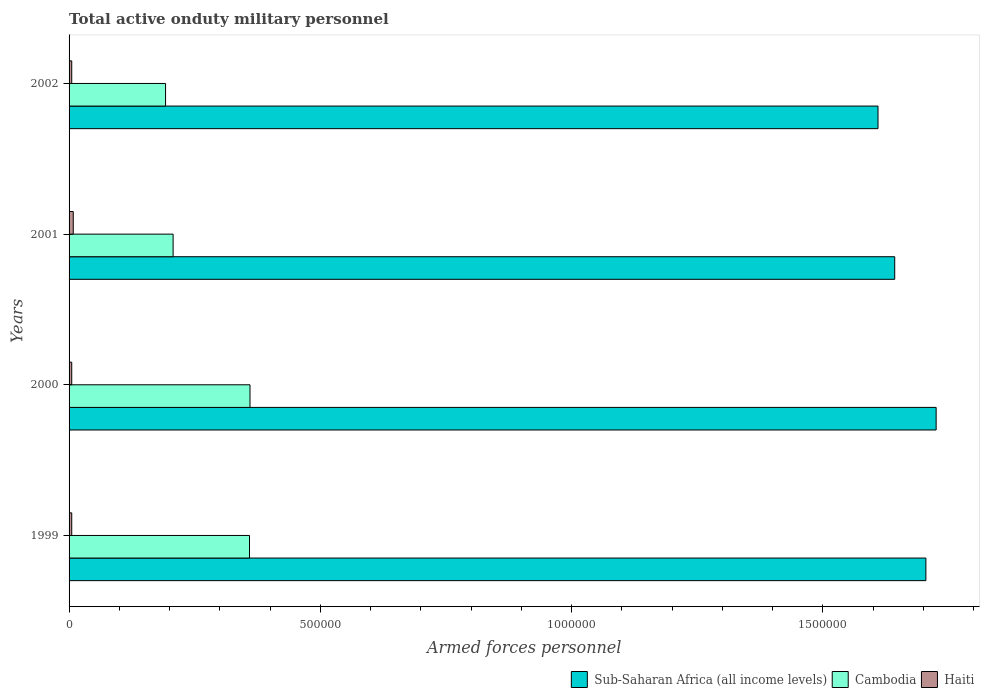How many different coloured bars are there?
Your answer should be compact. 3. How many groups of bars are there?
Your response must be concise. 4. Are the number of bars on each tick of the Y-axis equal?
Give a very brief answer. Yes. How many bars are there on the 3rd tick from the bottom?
Offer a very short reply. 3. What is the number of armed forces personnel in Sub-Saharan Africa (all income levels) in 2002?
Your answer should be compact. 1.61e+06. Across all years, what is the maximum number of armed forces personnel in Cambodia?
Provide a short and direct response. 3.60e+05. Across all years, what is the minimum number of armed forces personnel in Sub-Saharan Africa (all income levels)?
Your answer should be compact. 1.61e+06. In which year was the number of armed forces personnel in Haiti maximum?
Provide a short and direct response. 2001. In which year was the number of armed forces personnel in Sub-Saharan Africa (all income levels) minimum?
Give a very brief answer. 2002. What is the total number of armed forces personnel in Cambodia in the graph?
Ensure brevity in your answer.  1.12e+06. What is the difference between the number of armed forces personnel in Haiti in 1999 and that in 2000?
Offer a terse response. 0. What is the difference between the number of armed forces personnel in Sub-Saharan Africa (all income levels) in 2001 and the number of armed forces personnel in Cambodia in 2002?
Your response must be concise. 1.45e+06. What is the average number of armed forces personnel in Cambodia per year?
Offer a very short reply. 2.80e+05. In the year 2000, what is the difference between the number of armed forces personnel in Sub-Saharan Africa (all income levels) and number of armed forces personnel in Haiti?
Your answer should be compact. 1.72e+06. What is the ratio of the number of armed forces personnel in Cambodia in 2000 to that in 2002?
Ensure brevity in your answer.  1.88. Is the difference between the number of armed forces personnel in Sub-Saharan Africa (all income levels) in 1999 and 2002 greater than the difference between the number of armed forces personnel in Haiti in 1999 and 2002?
Your answer should be compact. Yes. What is the difference between the highest and the second highest number of armed forces personnel in Haiti?
Provide a succinct answer. 3000. What is the difference between the highest and the lowest number of armed forces personnel in Haiti?
Make the answer very short. 3000. In how many years, is the number of armed forces personnel in Cambodia greater than the average number of armed forces personnel in Cambodia taken over all years?
Provide a succinct answer. 2. Is the sum of the number of armed forces personnel in Sub-Saharan Africa (all income levels) in 2001 and 2002 greater than the maximum number of armed forces personnel in Cambodia across all years?
Offer a terse response. Yes. What does the 2nd bar from the top in 2000 represents?
Provide a succinct answer. Cambodia. What does the 2nd bar from the bottom in 1999 represents?
Keep it short and to the point. Cambodia. Is it the case that in every year, the sum of the number of armed forces personnel in Cambodia and number of armed forces personnel in Haiti is greater than the number of armed forces personnel in Sub-Saharan Africa (all income levels)?
Your response must be concise. No. Are all the bars in the graph horizontal?
Your answer should be very brief. Yes. How many years are there in the graph?
Ensure brevity in your answer.  4. Does the graph contain grids?
Make the answer very short. No. How many legend labels are there?
Provide a short and direct response. 3. What is the title of the graph?
Provide a succinct answer. Total active onduty military personnel. What is the label or title of the X-axis?
Offer a very short reply. Armed forces personnel. What is the label or title of the Y-axis?
Give a very brief answer. Years. What is the Armed forces personnel of Sub-Saharan Africa (all income levels) in 1999?
Offer a terse response. 1.70e+06. What is the Armed forces personnel in Cambodia in 1999?
Your answer should be compact. 3.59e+05. What is the Armed forces personnel in Haiti in 1999?
Offer a very short reply. 5300. What is the Armed forces personnel in Sub-Saharan Africa (all income levels) in 2000?
Your response must be concise. 1.73e+06. What is the Armed forces personnel of Cambodia in 2000?
Provide a short and direct response. 3.60e+05. What is the Armed forces personnel in Haiti in 2000?
Offer a terse response. 5300. What is the Armed forces personnel in Sub-Saharan Africa (all income levels) in 2001?
Keep it short and to the point. 1.64e+06. What is the Armed forces personnel of Cambodia in 2001?
Provide a succinct answer. 2.07e+05. What is the Armed forces personnel of Haiti in 2001?
Provide a succinct answer. 8300. What is the Armed forces personnel in Sub-Saharan Africa (all income levels) in 2002?
Provide a short and direct response. 1.61e+06. What is the Armed forces personnel in Cambodia in 2002?
Provide a succinct answer. 1.92e+05. What is the Armed forces personnel in Haiti in 2002?
Make the answer very short. 5300. Across all years, what is the maximum Armed forces personnel in Sub-Saharan Africa (all income levels)?
Your answer should be very brief. 1.73e+06. Across all years, what is the maximum Armed forces personnel in Cambodia?
Offer a terse response. 3.60e+05. Across all years, what is the maximum Armed forces personnel of Haiti?
Keep it short and to the point. 8300. Across all years, what is the minimum Armed forces personnel of Sub-Saharan Africa (all income levels)?
Make the answer very short. 1.61e+06. Across all years, what is the minimum Armed forces personnel of Cambodia?
Make the answer very short. 1.92e+05. Across all years, what is the minimum Armed forces personnel in Haiti?
Provide a succinct answer. 5300. What is the total Armed forces personnel in Sub-Saharan Africa (all income levels) in the graph?
Your answer should be very brief. 6.68e+06. What is the total Armed forces personnel of Cambodia in the graph?
Provide a short and direct response. 1.12e+06. What is the total Armed forces personnel of Haiti in the graph?
Your answer should be very brief. 2.42e+04. What is the difference between the Armed forces personnel of Sub-Saharan Africa (all income levels) in 1999 and that in 2000?
Ensure brevity in your answer.  -2.04e+04. What is the difference between the Armed forces personnel in Cambodia in 1999 and that in 2000?
Provide a short and direct response. -1000. What is the difference between the Armed forces personnel in Sub-Saharan Africa (all income levels) in 1999 and that in 2001?
Provide a short and direct response. 6.20e+04. What is the difference between the Armed forces personnel of Cambodia in 1999 and that in 2001?
Give a very brief answer. 1.52e+05. What is the difference between the Armed forces personnel in Haiti in 1999 and that in 2001?
Provide a succinct answer. -3000. What is the difference between the Armed forces personnel in Sub-Saharan Africa (all income levels) in 1999 and that in 2002?
Your answer should be very brief. 9.52e+04. What is the difference between the Armed forces personnel of Cambodia in 1999 and that in 2002?
Ensure brevity in your answer.  1.67e+05. What is the difference between the Armed forces personnel in Sub-Saharan Africa (all income levels) in 2000 and that in 2001?
Keep it short and to the point. 8.24e+04. What is the difference between the Armed forces personnel of Cambodia in 2000 and that in 2001?
Ensure brevity in your answer.  1.53e+05. What is the difference between the Armed forces personnel of Haiti in 2000 and that in 2001?
Your answer should be very brief. -3000. What is the difference between the Armed forces personnel in Sub-Saharan Africa (all income levels) in 2000 and that in 2002?
Your response must be concise. 1.16e+05. What is the difference between the Armed forces personnel of Cambodia in 2000 and that in 2002?
Give a very brief answer. 1.68e+05. What is the difference between the Armed forces personnel in Haiti in 2000 and that in 2002?
Keep it short and to the point. 0. What is the difference between the Armed forces personnel in Sub-Saharan Africa (all income levels) in 2001 and that in 2002?
Give a very brief answer. 3.32e+04. What is the difference between the Armed forces personnel of Cambodia in 2001 and that in 2002?
Make the answer very short. 1.50e+04. What is the difference between the Armed forces personnel in Haiti in 2001 and that in 2002?
Your response must be concise. 3000. What is the difference between the Armed forces personnel in Sub-Saharan Africa (all income levels) in 1999 and the Armed forces personnel in Cambodia in 2000?
Make the answer very short. 1.34e+06. What is the difference between the Armed forces personnel in Sub-Saharan Africa (all income levels) in 1999 and the Armed forces personnel in Haiti in 2000?
Make the answer very short. 1.70e+06. What is the difference between the Armed forces personnel in Cambodia in 1999 and the Armed forces personnel in Haiti in 2000?
Ensure brevity in your answer.  3.54e+05. What is the difference between the Armed forces personnel of Sub-Saharan Africa (all income levels) in 1999 and the Armed forces personnel of Cambodia in 2001?
Offer a terse response. 1.50e+06. What is the difference between the Armed forces personnel in Sub-Saharan Africa (all income levels) in 1999 and the Armed forces personnel in Haiti in 2001?
Your answer should be very brief. 1.70e+06. What is the difference between the Armed forces personnel in Cambodia in 1999 and the Armed forces personnel in Haiti in 2001?
Offer a terse response. 3.51e+05. What is the difference between the Armed forces personnel of Sub-Saharan Africa (all income levels) in 1999 and the Armed forces personnel of Cambodia in 2002?
Offer a very short reply. 1.51e+06. What is the difference between the Armed forces personnel of Sub-Saharan Africa (all income levels) in 1999 and the Armed forces personnel of Haiti in 2002?
Give a very brief answer. 1.70e+06. What is the difference between the Armed forces personnel of Cambodia in 1999 and the Armed forces personnel of Haiti in 2002?
Make the answer very short. 3.54e+05. What is the difference between the Armed forces personnel of Sub-Saharan Africa (all income levels) in 2000 and the Armed forces personnel of Cambodia in 2001?
Provide a succinct answer. 1.52e+06. What is the difference between the Armed forces personnel of Sub-Saharan Africa (all income levels) in 2000 and the Armed forces personnel of Haiti in 2001?
Provide a short and direct response. 1.72e+06. What is the difference between the Armed forces personnel in Cambodia in 2000 and the Armed forces personnel in Haiti in 2001?
Give a very brief answer. 3.52e+05. What is the difference between the Armed forces personnel in Sub-Saharan Africa (all income levels) in 2000 and the Armed forces personnel in Cambodia in 2002?
Give a very brief answer. 1.53e+06. What is the difference between the Armed forces personnel of Sub-Saharan Africa (all income levels) in 2000 and the Armed forces personnel of Haiti in 2002?
Make the answer very short. 1.72e+06. What is the difference between the Armed forces personnel of Cambodia in 2000 and the Armed forces personnel of Haiti in 2002?
Offer a very short reply. 3.55e+05. What is the difference between the Armed forces personnel of Sub-Saharan Africa (all income levels) in 2001 and the Armed forces personnel of Cambodia in 2002?
Provide a short and direct response. 1.45e+06. What is the difference between the Armed forces personnel of Sub-Saharan Africa (all income levels) in 2001 and the Armed forces personnel of Haiti in 2002?
Provide a succinct answer. 1.64e+06. What is the difference between the Armed forces personnel in Cambodia in 2001 and the Armed forces personnel in Haiti in 2002?
Your answer should be compact. 2.02e+05. What is the average Armed forces personnel of Sub-Saharan Africa (all income levels) per year?
Your answer should be very brief. 1.67e+06. What is the average Armed forces personnel in Cambodia per year?
Your response must be concise. 2.80e+05. What is the average Armed forces personnel of Haiti per year?
Your answer should be very brief. 6050. In the year 1999, what is the difference between the Armed forces personnel in Sub-Saharan Africa (all income levels) and Armed forces personnel in Cambodia?
Provide a short and direct response. 1.35e+06. In the year 1999, what is the difference between the Armed forces personnel of Sub-Saharan Africa (all income levels) and Armed forces personnel of Haiti?
Your response must be concise. 1.70e+06. In the year 1999, what is the difference between the Armed forces personnel of Cambodia and Armed forces personnel of Haiti?
Offer a terse response. 3.54e+05. In the year 2000, what is the difference between the Armed forces personnel in Sub-Saharan Africa (all income levels) and Armed forces personnel in Cambodia?
Provide a short and direct response. 1.37e+06. In the year 2000, what is the difference between the Armed forces personnel in Sub-Saharan Africa (all income levels) and Armed forces personnel in Haiti?
Ensure brevity in your answer.  1.72e+06. In the year 2000, what is the difference between the Armed forces personnel of Cambodia and Armed forces personnel of Haiti?
Keep it short and to the point. 3.55e+05. In the year 2001, what is the difference between the Armed forces personnel in Sub-Saharan Africa (all income levels) and Armed forces personnel in Cambodia?
Keep it short and to the point. 1.44e+06. In the year 2001, what is the difference between the Armed forces personnel in Sub-Saharan Africa (all income levels) and Armed forces personnel in Haiti?
Your answer should be compact. 1.63e+06. In the year 2001, what is the difference between the Armed forces personnel in Cambodia and Armed forces personnel in Haiti?
Provide a short and direct response. 1.99e+05. In the year 2002, what is the difference between the Armed forces personnel of Sub-Saharan Africa (all income levels) and Armed forces personnel of Cambodia?
Provide a short and direct response. 1.42e+06. In the year 2002, what is the difference between the Armed forces personnel in Sub-Saharan Africa (all income levels) and Armed forces personnel in Haiti?
Provide a short and direct response. 1.60e+06. In the year 2002, what is the difference between the Armed forces personnel in Cambodia and Armed forces personnel in Haiti?
Offer a terse response. 1.87e+05. What is the ratio of the Armed forces personnel of Haiti in 1999 to that in 2000?
Give a very brief answer. 1. What is the ratio of the Armed forces personnel of Sub-Saharan Africa (all income levels) in 1999 to that in 2001?
Make the answer very short. 1.04. What is the ratio of the Armed forces personnel in Cambodia in 1999 to that in 2001?
Keep it short and to the point. 1.73. What is the ratio of the Armed forces personnel of Haiti in 1999 to that in 2001?
Your response must be concise. 0.64. What is the ratio of the Armed forces personnel in Sub-Saharan Africa (all income levels) in 1999 to that in 2002?
Offer a terse response. 1.06. What is the ratio of the Armed forces personnel of Cambodia in 1999 to that in 2002?
Provide a short and direct response. 1.87. What is the ratio of the Armed forces personnel in Haiti in 1999 to that in 2002?
Make the answer very short. 1. What is the ratio of the Armed forces personnel in Sub-Saharan Africa (all income levels) in 2000 to that in 2001?
Your response must be concise. 1.05. What is the ratio of the Armed forces personnel of Cambodia in 2000 to that in 2001?
Offer a very short reply. 1.74. What is the ratio of the Armed forces personnel of Haiti in 2000 to that in 2001?
Your answer should be compact. 0.64. What is the ratio of the Armed forces personnel of Sub-Saharan Africa (all income levels) in 2000 to that in 2002?
Give a very brief answer. 1.07. What is the ratio of the Armed forces personnel of Cambodia in 2000 to that in 2002?
Provide a short and direct response. 1.88. What is the ratio of the Armed forces personnel in Haiti in 2000 to that in 2002?
Your answer should be compact. 1. What is the ratio of the Armed forces personnel of Sub-Saharan Africa (all income levels) in 2001 to that in 2002?
Your answer should be compact. 1.02. What is the ratio of the Armed forces personnel in Cambodia in 2001 to that in 2002?
Make the answer very short. 1.08. What is the ratio of the Armed forces personnel in Haiti in 2001 to that in 2002?
Provide a short and direct response. 1.57. What is the difference between the highest and the second highest Armed forces personnel in Sub-Saharan Africa (all income levels)?
Ensure brevity in your answer.  2.04e+04. What is the difference between the highest and the second highest Armed forces personnel in Cambodia?
Make the answer very short. 1000. What is the difference between the highest and the second highest Armed forces personnel in Haiti?
Your answer should be very brief. 3000. What is the difference between the highest and the lowest Armed forces personnel of Sub-Saharan Africa (all income levels)?
Ensure brevity in your answer.  1.16e+05. What is the difference between the highest and the lowest Armed forces personnel of Cambodia?
Make the answer very short. 1.68e+05. What is the difference between the highest and the lowest Armed forces personnel of Haiti?
Provide a short and direct response. 3000. 